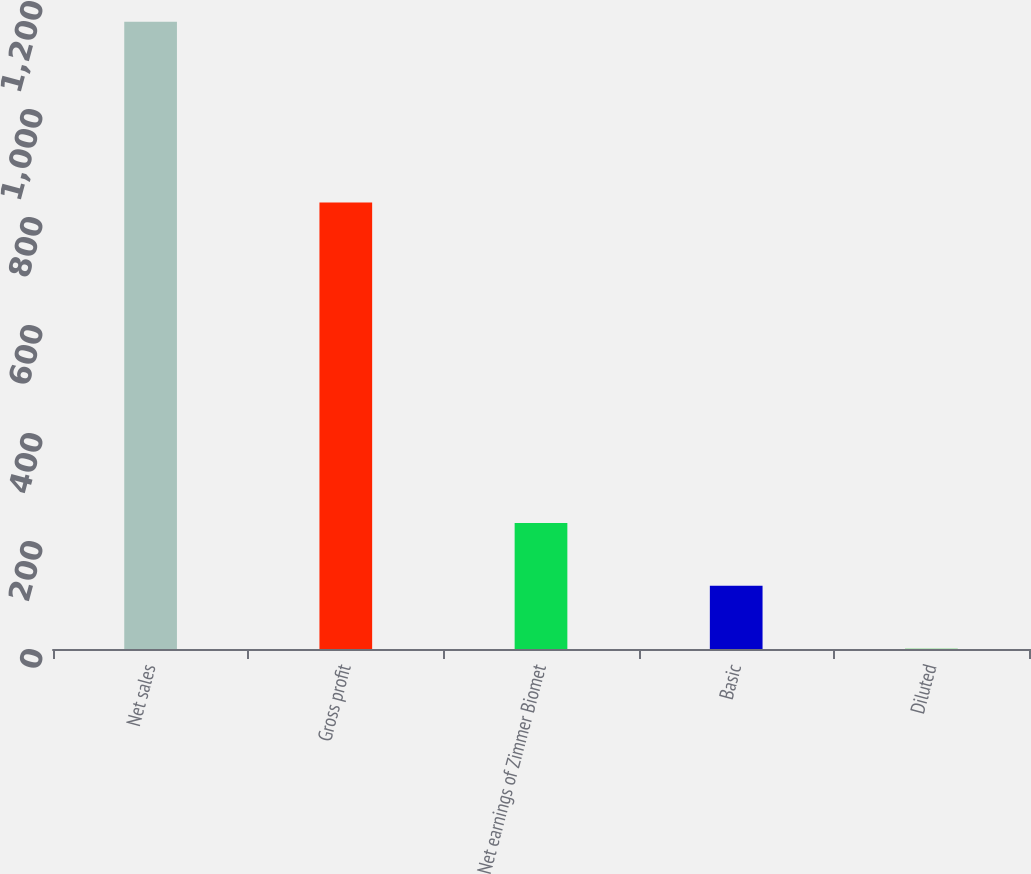Convert chart to OTSL. <chart><loc_0><loc_0><loc_500><loc_500><bar_chart><fcel>Net sales<fcel>Gross profit<fcel>Net earnings of Zimmer Biomet<fcel>Basic<fcel>Diluted<nl><fcel>1161.5<fcel>826.8<fcel>233.33<fcel>117.31<fcel>1.29<nl></chart> 